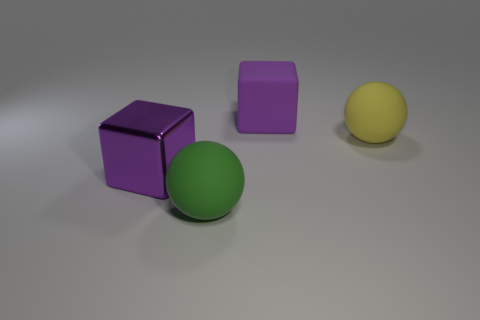How many green spheres have the same material as the big green thing?
Ensure brevity in your answer.  0. The big ball behind the object in front of the big purple object to the left of the green rubber ball is made of what material?
Provide a short and direct response. Rubber. What is the color of the big object behind the big ball right of the green rubber sphere?
Offer a very short reply. Purple. The block that is the same size as the metal object is what color?
Ensure brevity in your answer.  Purple. How many big things are purple matte blocks or green spheres?
Keep it short and to the point. 2. Is the number of big purple metal things right of the large purple shiny cube greater than the number of big green spheres to the right of the yellow ball?
Provide a succinct answer. No. What size is the matte object that is the same color as the metallic object?
Provide a succinct answer. Large. What number of other things are there of the same size as the green rubber object?
Provide a short and direct response. 3. Is the block that is behind the purple metal thing made of the same material as the yellow ball?
Give a very brief answer. Yes. What number of other things are there of the same color as the big metallic thing?
Ensure brevity in your answer.  1. 